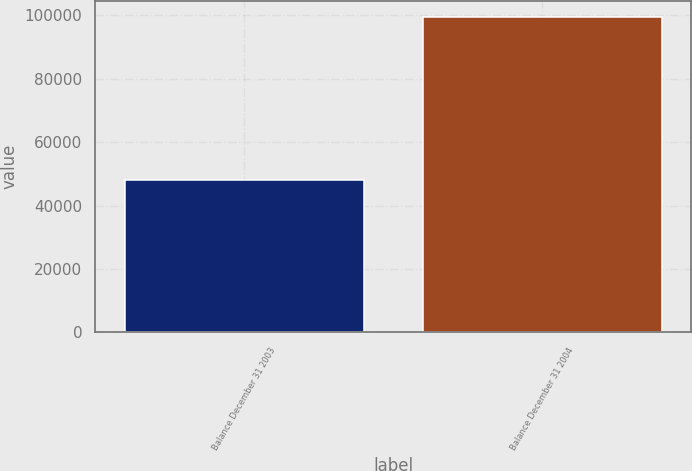Convert chart. <chart><loc_0><loc_0><loc_500><loc_500><bar_chart><fcel>Balance December 31 2003<fcel>Balance December 31 2004<nl><fcel>47980<fcel>99645<nl></chart> 